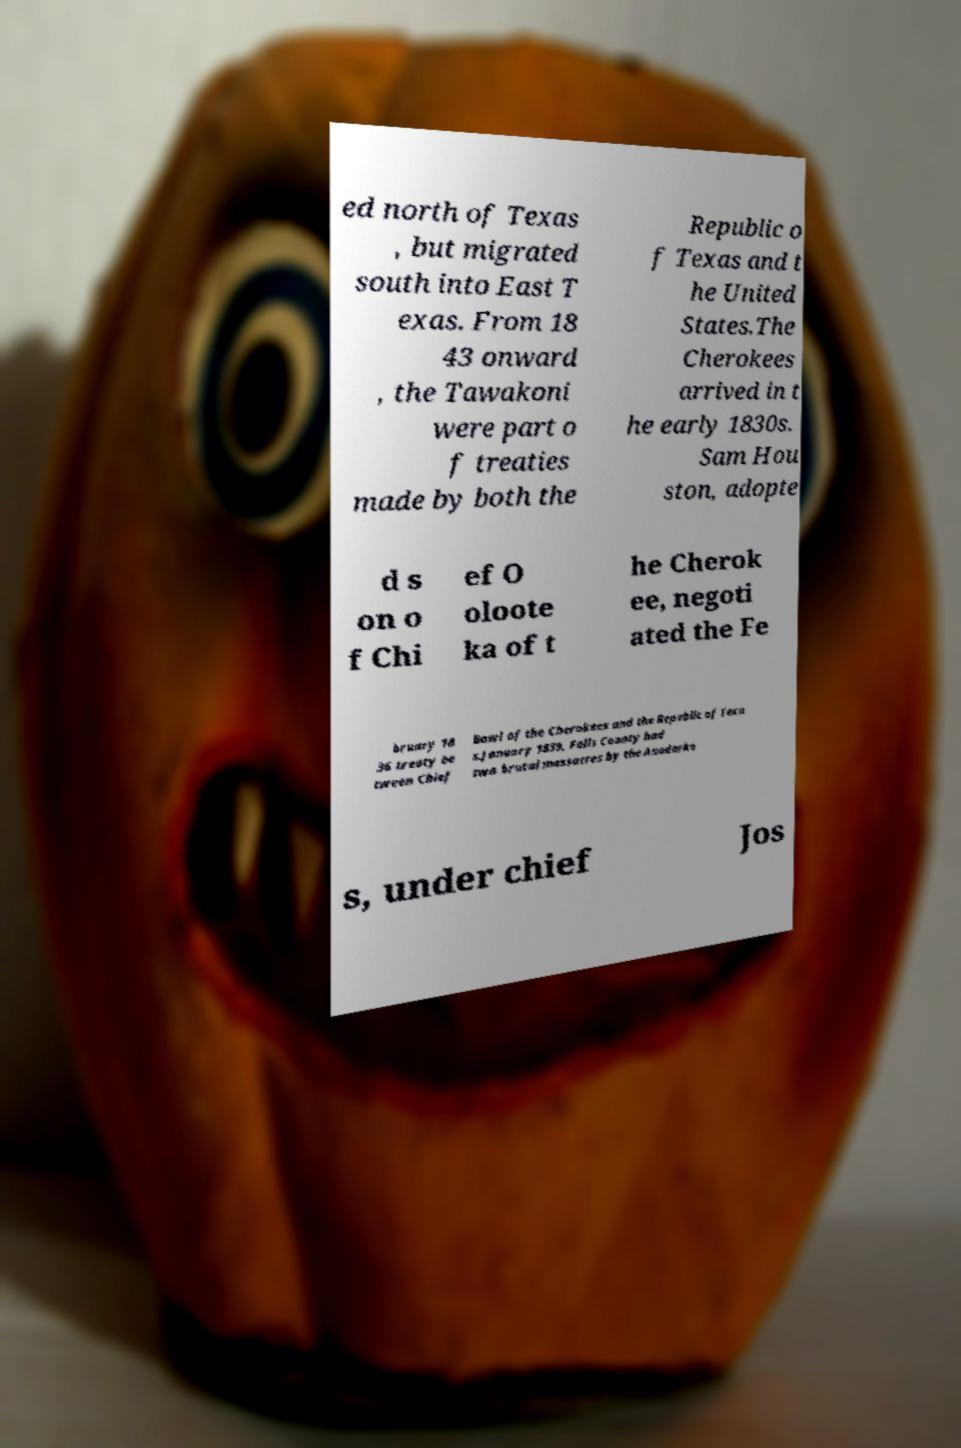Can you read and provide the text displayed in the image?This photo seems to have some interesting text. Can you extract and type it out for me? ed north of Texas , but migrated south into East T exas. From 18 43 onward , the Tawakoni were part o f treaties made by both the Republic o f Texas and t he United States.The Cherokees arrived in t he early 1830s. Sam Hou ston, adopte d s on o f Chi ef O oloote ka of t he Cherok ee, negoti ated the Fe bruary 18 36 treaty be tween Chief Bowl of the Cherokees and the Republic of Texa s.January 1839, Falls County had two brutal massacres by the Anadarko s, under chief Jos 